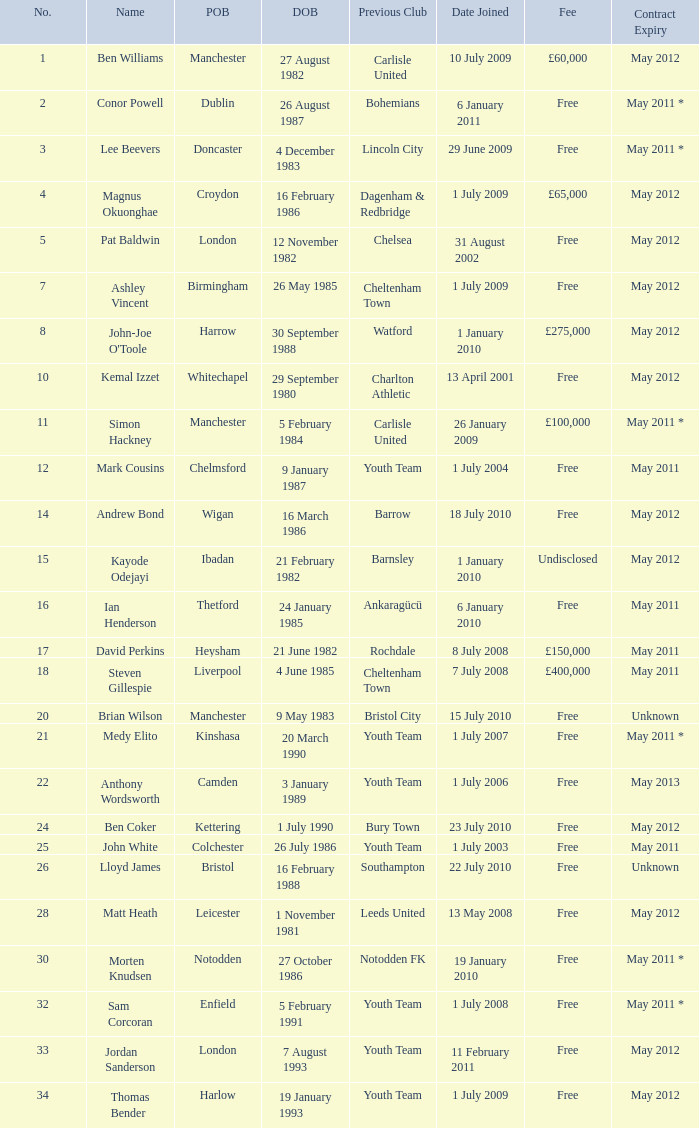What is the fee for ankaragücü previous club Free. 